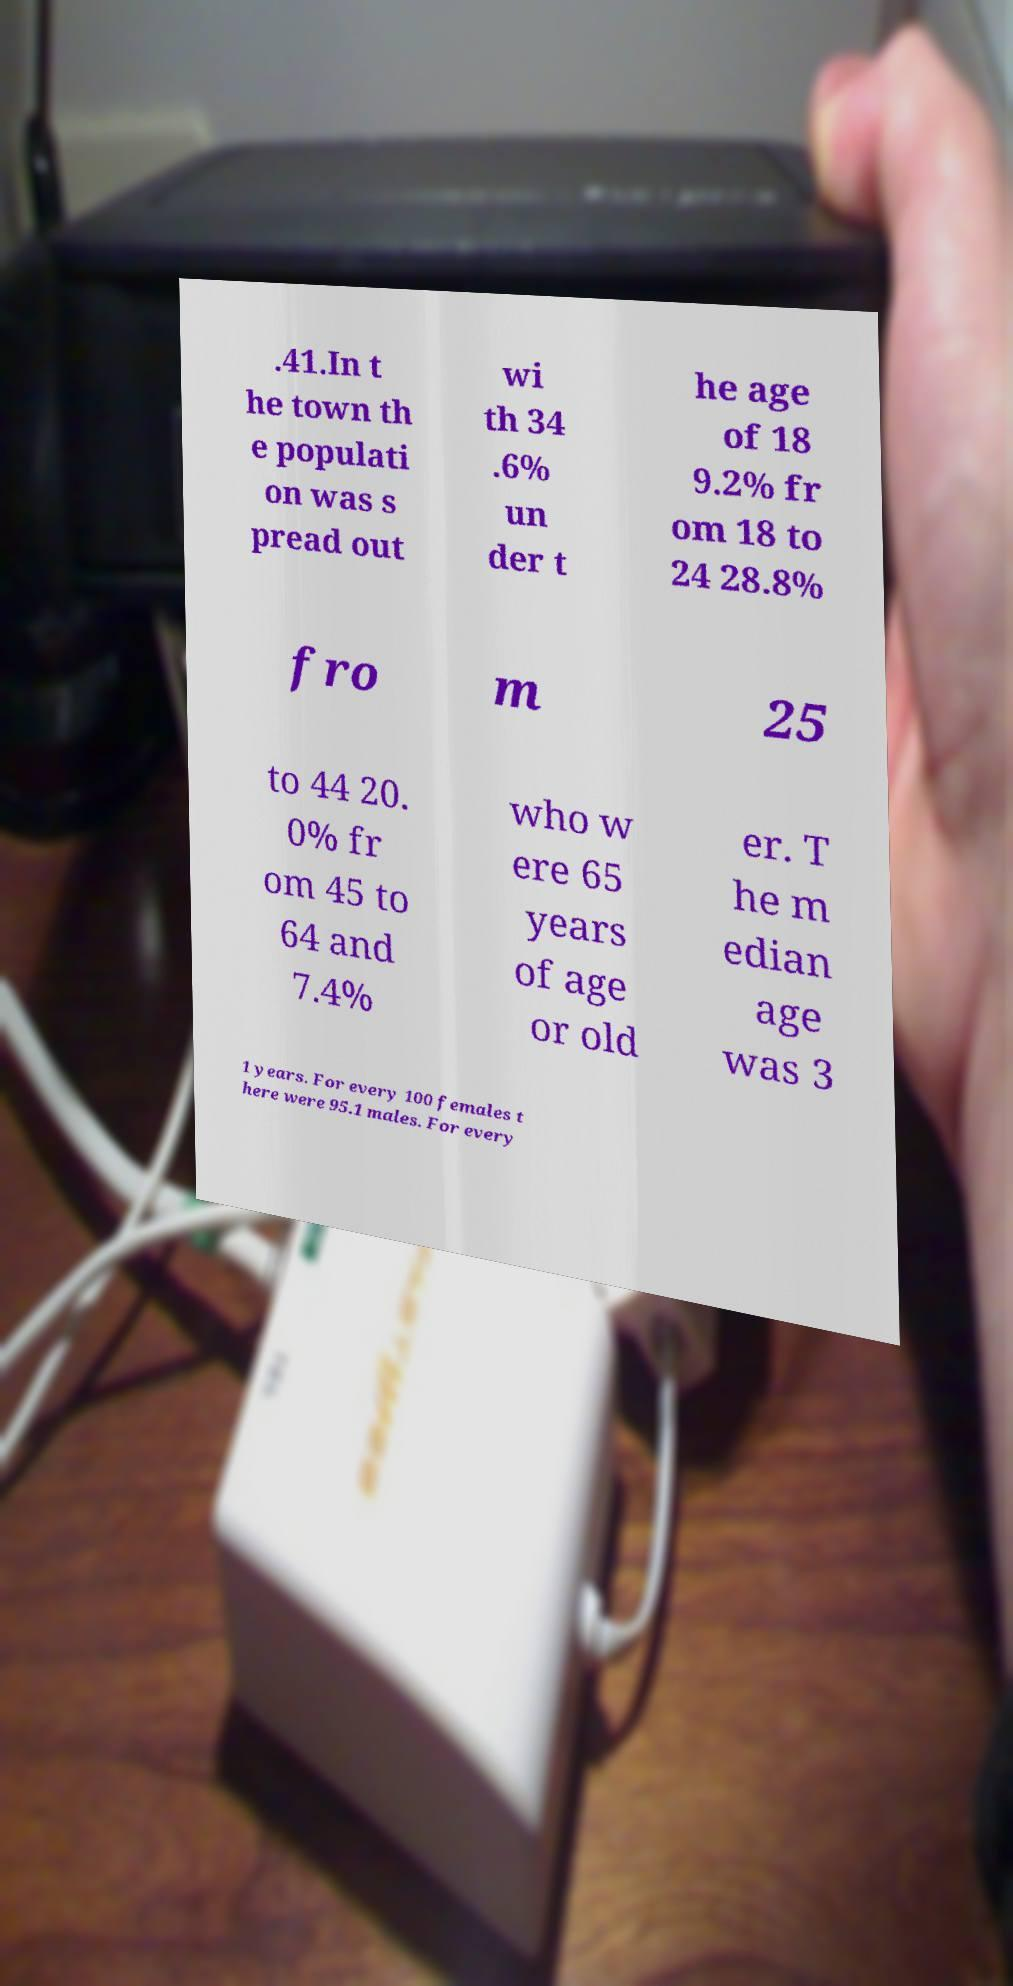Please read and relay the text visible in this image. What does it say? .41.In t he town th e populati on was s pread out wi th 34 .6% un der t he age of 18 9.2% fr om 18 to 24 28.8% fro m 25 to 44 20. 0% fr om 45 to 64 and 7.4% who w ere 65 years of age or old er. T he m edian age was 3 1 years. For every 100 females t here were 95.1 males. For every 